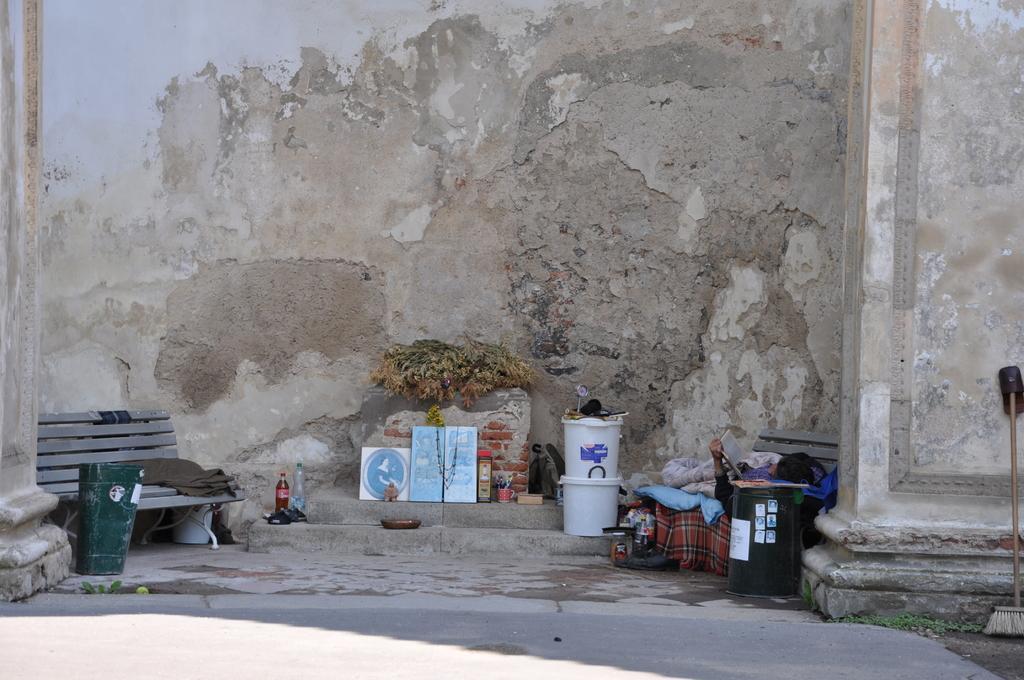Describe this image in one or two sentences. In this image I can see benches,green box,cup,bottles,clothes,one person is sleeping and holding a book and few objects on the floor. I can see a wall and pillar. 